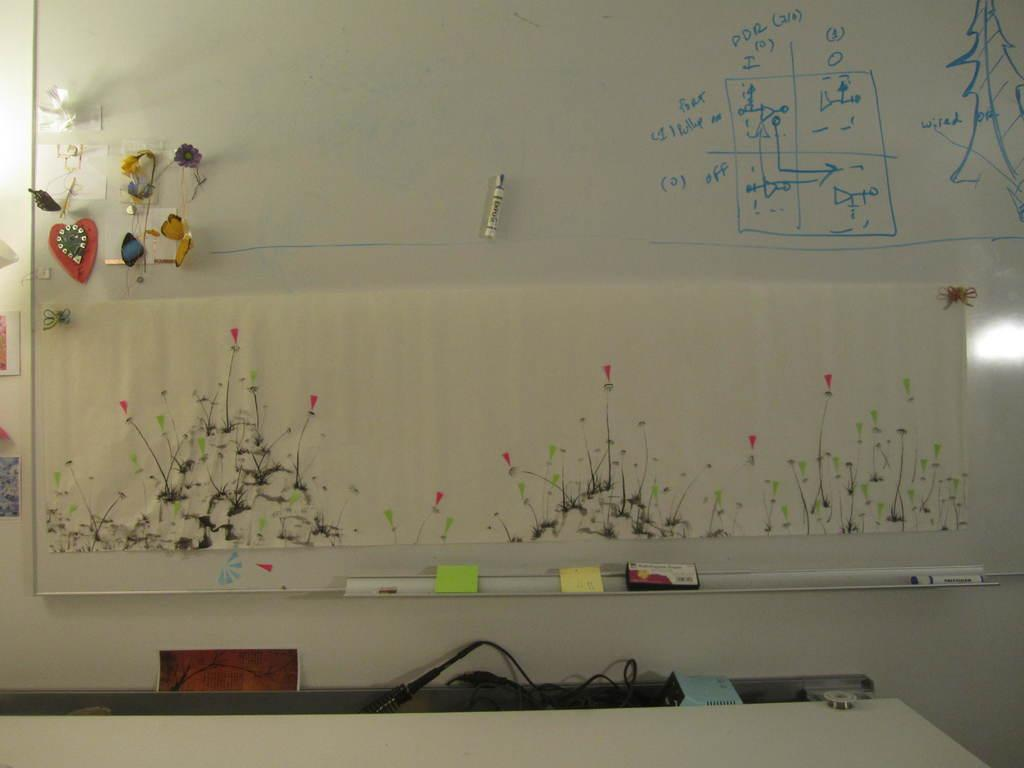What is the main object in the image? There is a board in the image. What is depicted on the board? There is artwork on the board. How were the diagrams created on the board? The diagrams were drawn on the board using a sketch pen. What can be seen in the background of the image? There is a wall in the background of the image. Are there any bushes visible in the image? No, there are no bushes present in the image. Can you see any mist in the image? No, there is no mist visible in the image. 